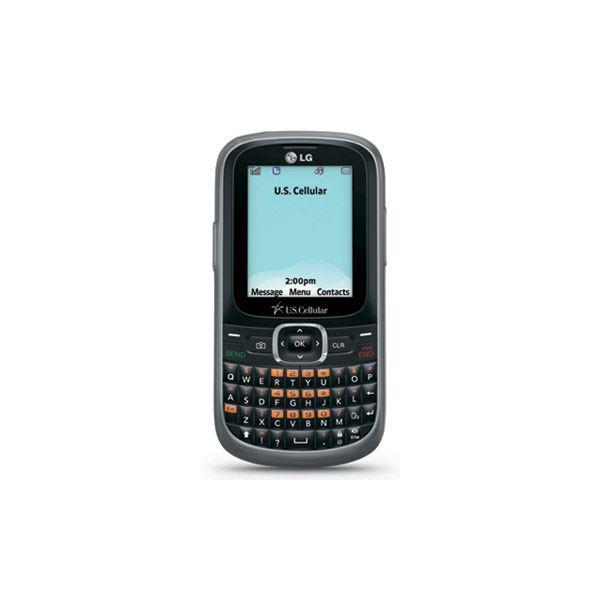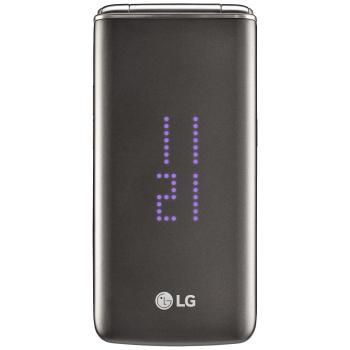The first image is the image on the left, the second image is the image on the right. Assess this claim about the two images: "One of the phones has keys that slide out from under the screen.". Correct or not? Answer yes or no. No. 